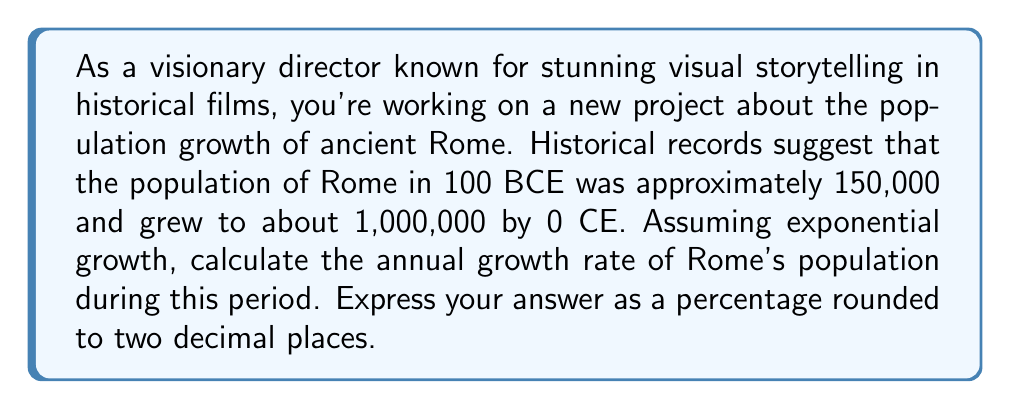Can you answer this question? To solve this problem, we'll use the exponential growth model:

$$P(t) = P_0 \cdot e^{rt}$$

Where:
$P(t)$ is the population at time $t$
$P_0$ is the initial population
$r$ is the annual growth rate
$t$ is the time in years

Given:
$P_0 = 150,000$ (population in 100 BCE)
$P(t) = 1,000,000$ (population in 0 CE)
$t = 100$ years

Let's plug these values into the equation:

$$1,000,000 = 150,000 \cdot e^{100r}$$

Now, let's solve for $r$:

1) Divide both sides by 150,000:
   $$\frac{1,000,000}{150,000} = e^{100r}$$

2) Simplify:
   $$\frac{20}{3} = e^{100r}$$

3) Take the natural log of both sides:
   $$\ln(\frac{20}{3}) = \ln(e^{100r})$$

4) Simplify the right side:
   $$\ln(\frac{20}{3}) = 100r$$

5) Solve for $r$:
   $$r = \frac{\ln(\frac{20}{3})}{100}$$

6) Calculate:
   $$r \approx 0.01897$$

7) Convert to a percentage:
   $$r \approx 1.897\%$$

8) Round to two decimal places:
   $$r \approx 1.90\%$$
Answer: 1.90% 